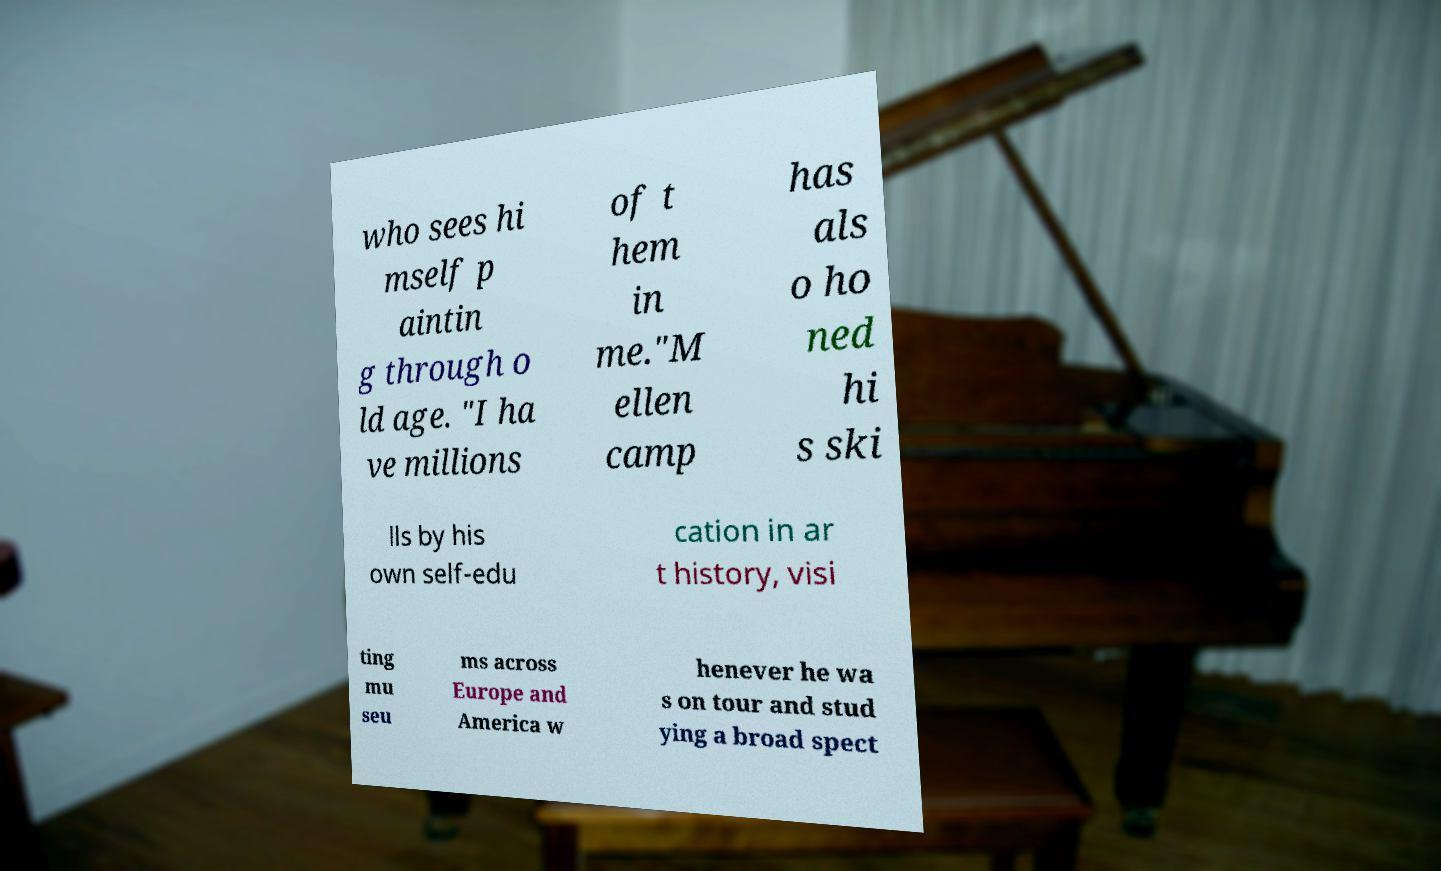Can you read and provide the text displayed in the image?This photo seems to have some interesting text. Can you extract and type it out for me? who sees hi mself p aintin g through o ld age. "I ha ve millions of t hem in me."M ellen camp has als o ho ned hi s ski lls by his own self-edu cation in ar t history, visi ting mu seu ms across Europe and America w henever he wa s on tour and stud ying a broad spect 